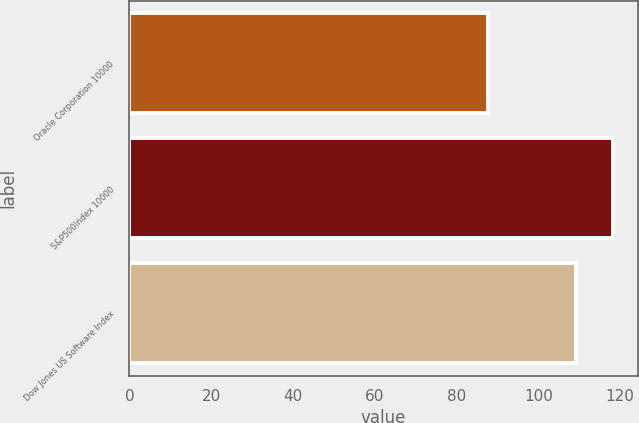<chart> <loc_0><loc_0><loc_500><loc_500><bar_chart><fcel>Oracle Corporation 10000<fcel>S&P500Index 10000<fcel>Dow Jones US Software Index<nl><fcel>87.62<fcel>118.32<fcel>109.22<nl></chart> 